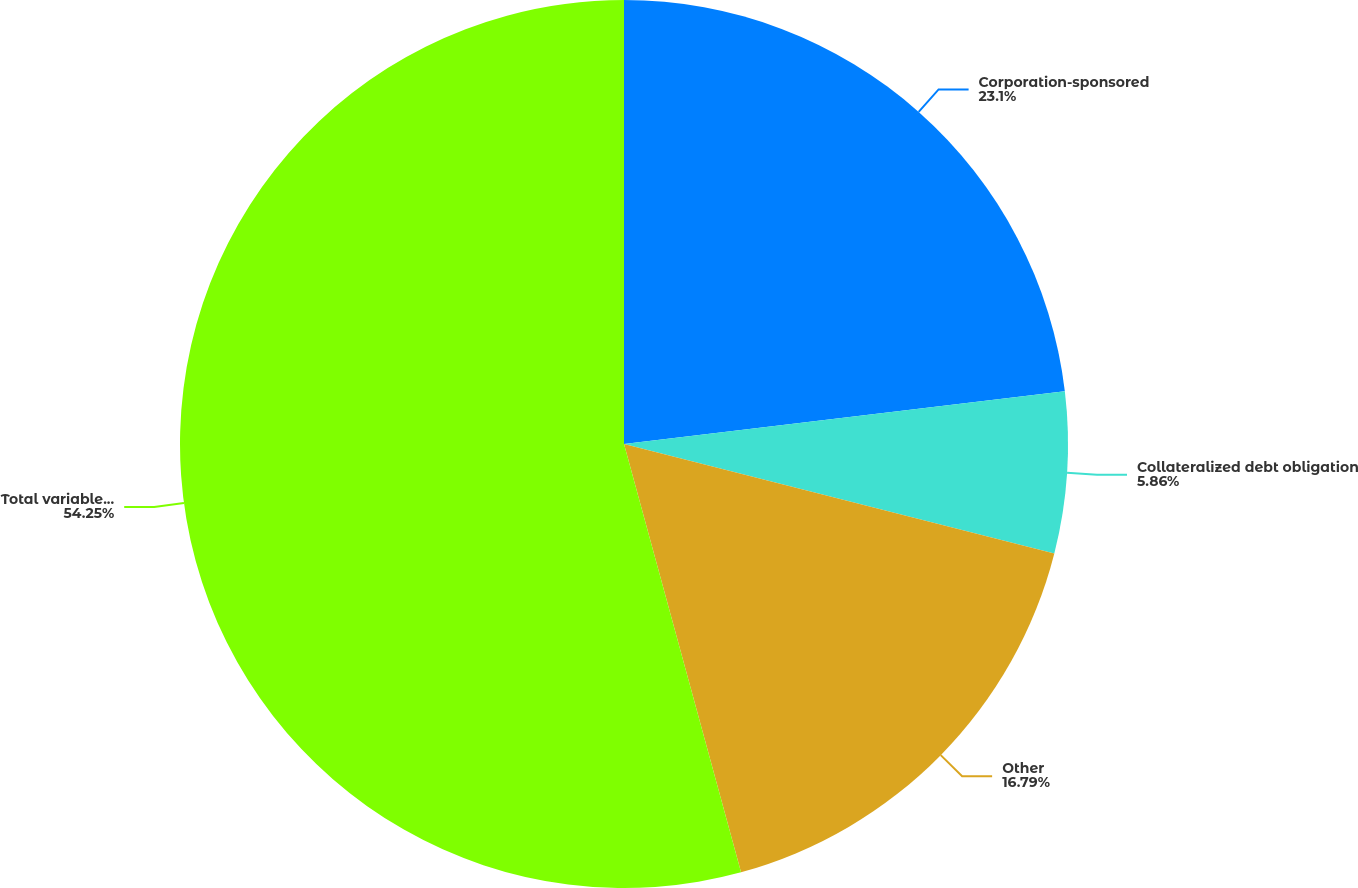Convert chart to OTSL. <chart><loc_0><loc_0><loc_500><loc_500><pie_chart><fcel>Corporation-sponsored<fcel>Collateralized debt obligation<fcel>Other<fcel>Total variable interest<nl><fcel>23.1%<fcel>5.86%<fcel>16.79%<fcel>54.24%<nl></chart> 